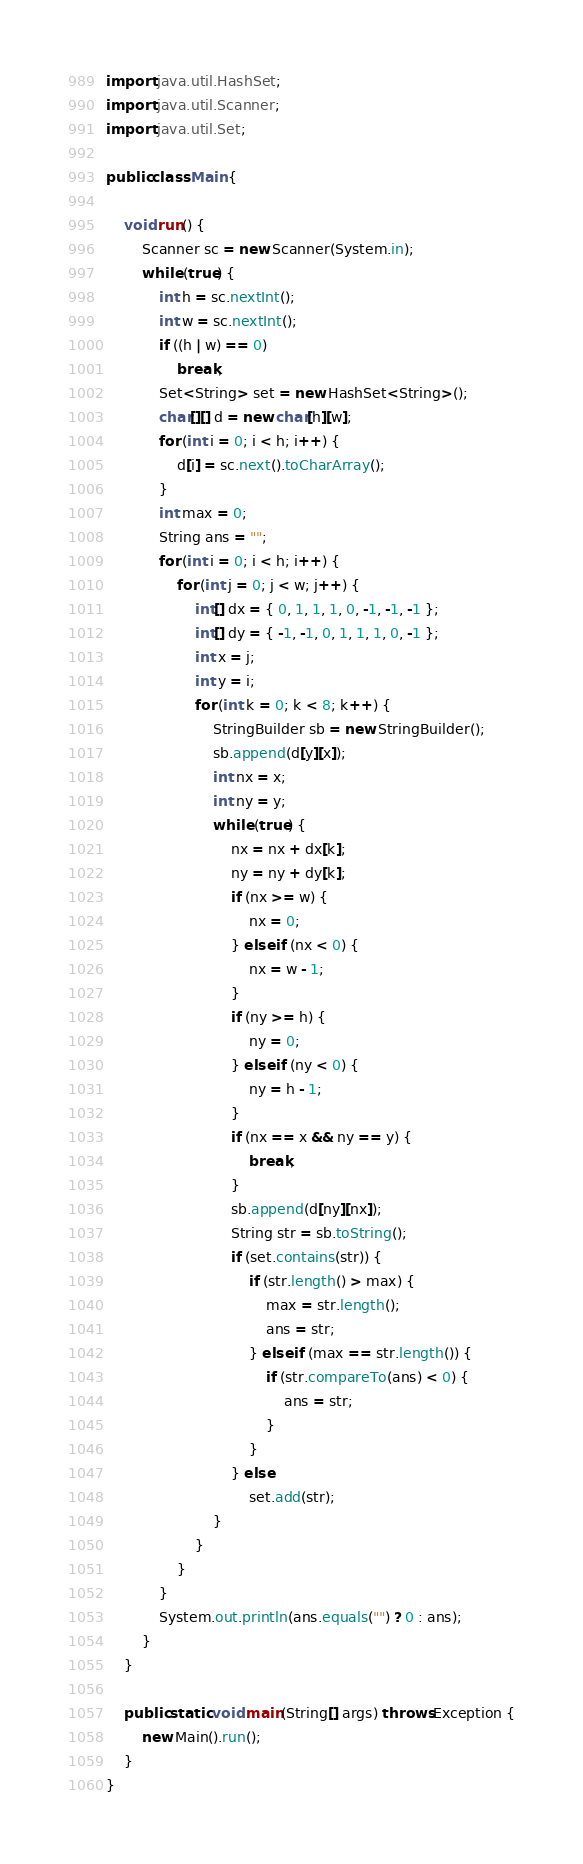Convert code to text. <code><loc_0><loc_0><loc_500><loc_500><_Java_>import java.util.HashSet;
import java.util.Scanner;
import java.util.Set;

public class Main {

    void run() {
        Scanner sc = new Scanner(System.in);
        while (true) {
            int h = sc.nextInt();
            int w = sc.nextInt();
            if ((h | w) == 0)
                break;
            Set<String> set = new HashSet<String>();
            char[][] d = new char[h][w];
            for (int i = 0; i < h; i++) {
                d[i] = sc.next().toCharArray();
            }
            int max = 0;
            String ans = "";
            for (int i = 0; i < h; i++) {
                for (int j = 0; j < w; j++) {
                    int[] dx = { 0, 1, 1, 1, 0, -1, -1, -1 };
                    int[] dy = { -1, -1, 0, 1, 1, 1, 0, -1 };
                    int x = j;
                    int y = i;
                    for (int k = 0; k < 8; k++) {
                        StringBuilder sb = new StringBuilder();
                        sb.append(d[y][x]);
                        int nx = x;
                        int ny = y;
                        while (true) {
                            nx = nx + dx[k];
                            ny = ny + dy[k];
                            if (nx >= w) {
                                nx = 0;
                            } else if (nx < 0) {
                                nx = w - 1;
                            }
                            if (ny >= h) {
                                ny = 0;
                            } else if (ny < 0) {
                                ny = h - 1;
                            }
                            if (nx == x && ny == y) {
                                break;
                            }
                            sb.append(d[ny][nx]);
                            String str = sb.toString();
                            if (set.contains(str)) {
                                if (str.length() > max) {
                                    max = str.length();
                                    ans = str;
                                } else if (max == str.length()) {
                                    if (str.compareTo(ans) < 0) {
                                        ans = str;
                                    }
                                }
                            } else
                                set.add(str);
                        }
                    }
                }
            }
            System.out.println(ans.equals("") ? 0 : ans);
        }
    }

    public static void main(String[] args) throws Exception {
        new Main().run();
    }
}</code> 